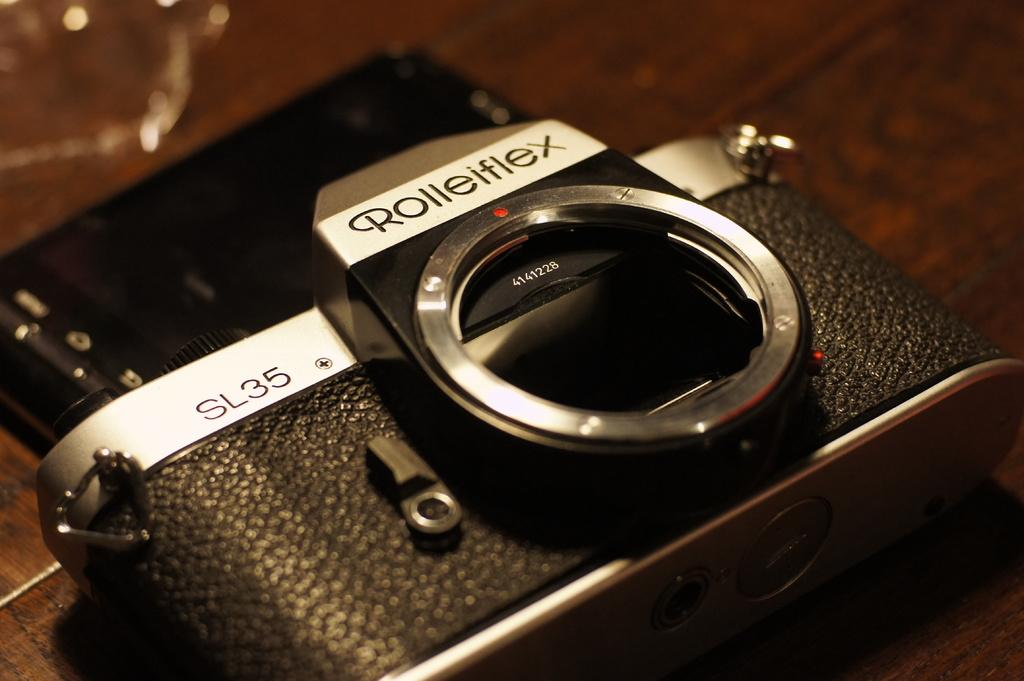What object is the main subject of the image? There is a camera in the image. Where is the camera placed? The camera is placed on a wooden surface. What additional details can be seen on the camera? There is text and numbers on the camera. What type of fruit is placed on top of the camera in the image? There is no fruit present on top of the camera in the image. What ornament is hanging from the camera in the image? There is no ornament hanging from the camera in the image. 